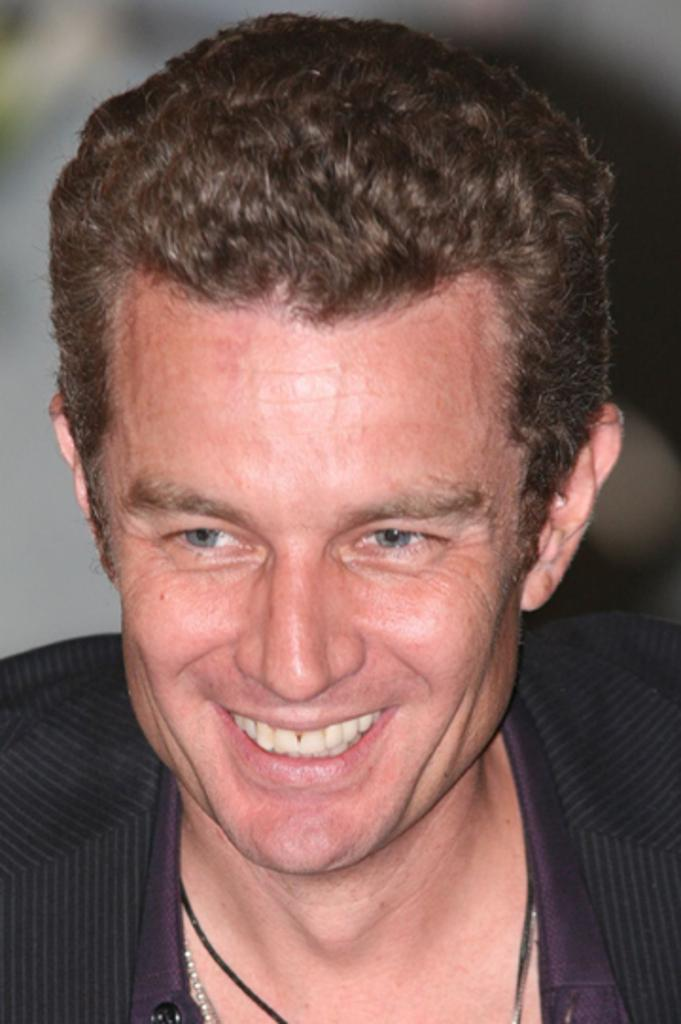Who is present in the image? There is a man in the image. What expression does the man have? The man is smiling. Can you describe the background of the image? The background of the image is blurry. What type of liquid is the girl drinking in the image? There is no girl present in the image, and therefore no liquid can be observed. 